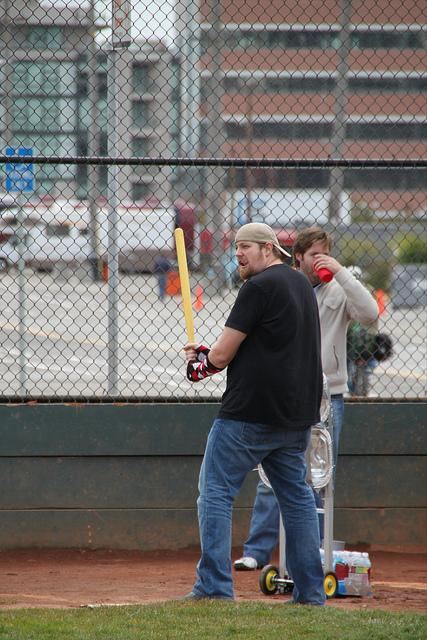What is the man in the black ready to do? Please explain your reasoning. swing. The man wants to swing. 